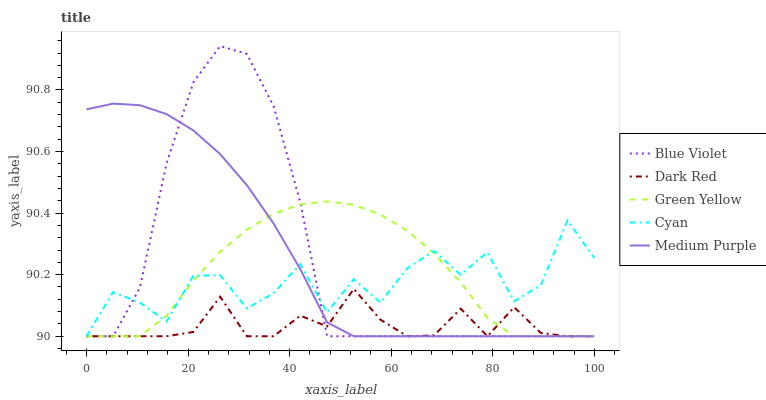Does Dark Red have the minimum area under the curve?
Answer yes or no. Yes. Does Medium Purple have the maximum area under the curve?
Answer yes or no. Yes. Does Green Yellow have the minimum area under the curve?
Answer yes or no. No. Does Green Yellow have the maximum area under the curve?
Answer yes or no. No. Is Medium Purple the smoothest?
Answer yes or no. Yes. Is Cyan the roughest?
Answer yes or no. Yes. Is Dark Red the smoothest?
Answer yes or no. No. Is Dark Red the roughest?
Answer yes or no. No. Does Medium Purple have the lowest value?
Answer yes or no. Yes. Does Blue Violet have the highest value?
Answer yes or no. Yes. Does Green Yellow have the highest value?
Answer yes or no. No. Does Cyan intersect Dark Red?
Answer yes or no. Yes. Is Cyan less than Dark Red?
Answer yes or no. No. Is Cyan greater than Dark Red?
Answer yes or no. No. 